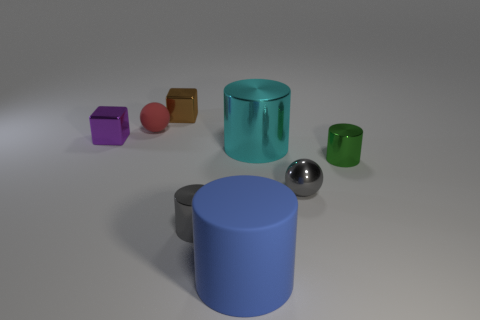What's the relationship between the shapes on the table? The objects on the surface appear to be an arrangement of geometric shapes and materials, possibly used to demonstrate differences in textures, reflections, and shadow casting in a 3D modeling environment. How could this kind of demonstration be useful? This kind of setup is often used in computer graphics and 3D modeling to test the rendering capabilities of a system, such as how light interacts with different surfaces or to showcase the visual properties of various materials. 